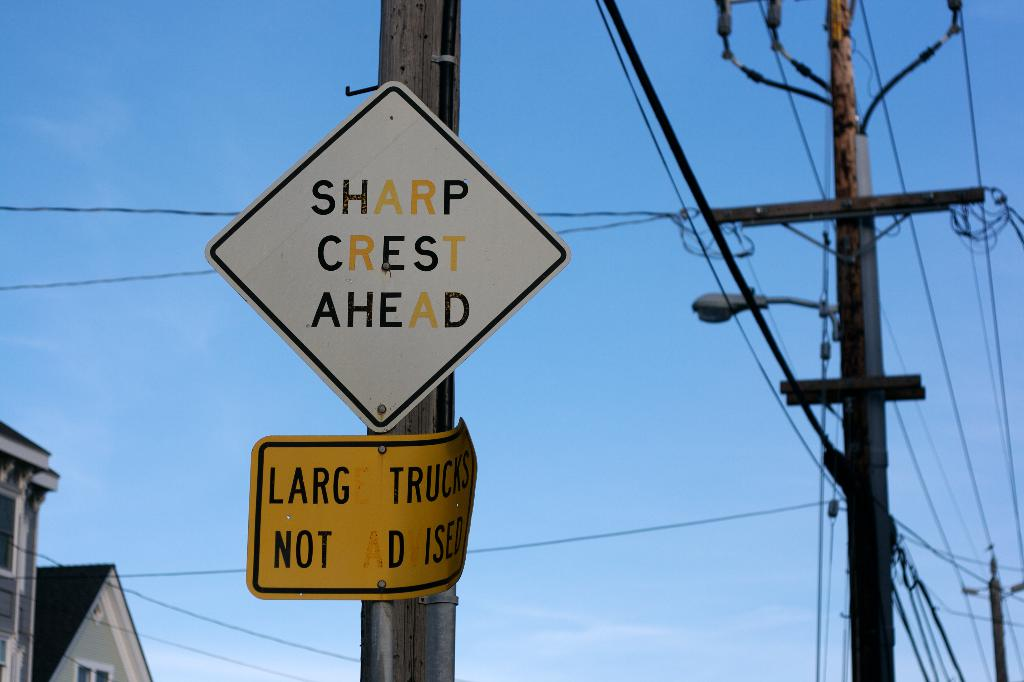How does the background context in the image relate to the signs shown? The residential setting indicated by the presence of house rooftops suggests the road is within a community. The power lines create a sense of verticality that reinforces the warning, visually implying the change in elevation the drivers might encounter beyond the framed view. 